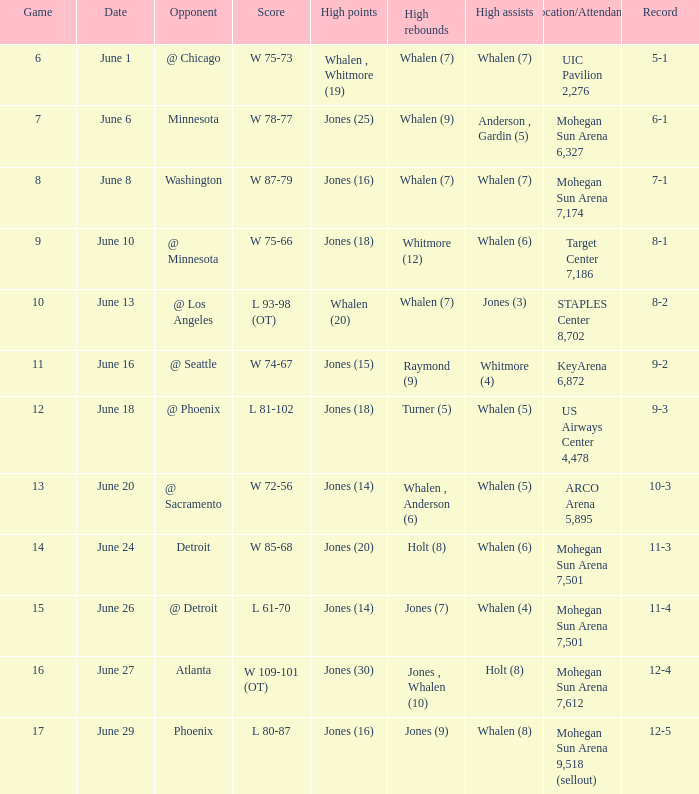What is the location/attendance when the record is 9-2? KeyArena 6,872. 